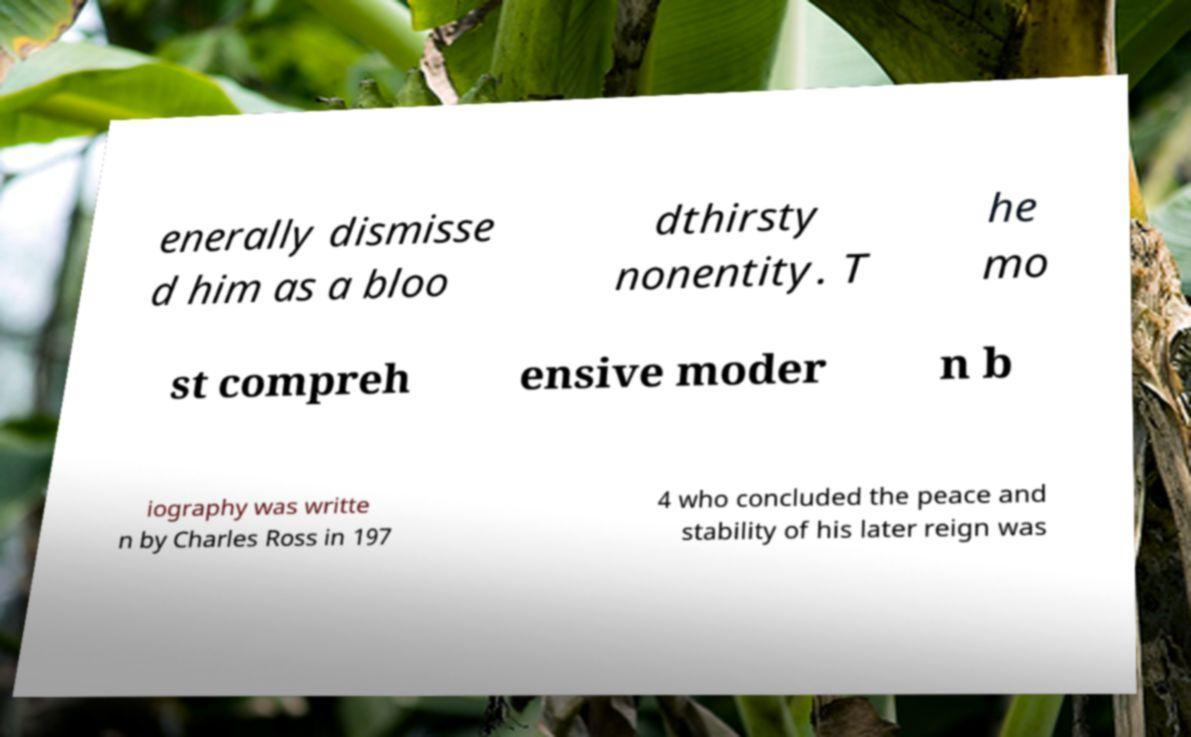There's text embedded in this image that I need extracted. Can you transcribe it verbatim? enerally dismisse d him as a bloo dthirsty nonentity. T he mo st compreh ensive moder n b iography was writte n by Charles Ross in 197 4 who concluded the peace and stability of his later reign was 